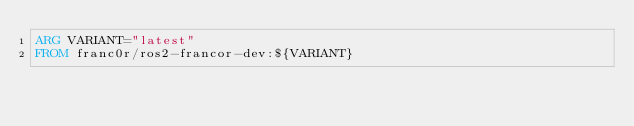<code> <loc_0><loc_0><loc_500><loc_500><_Dockerfile_>ARG VARIANT="latest"
FROM franc0r/ros2-francor-dev:${VARIANT}</code> 